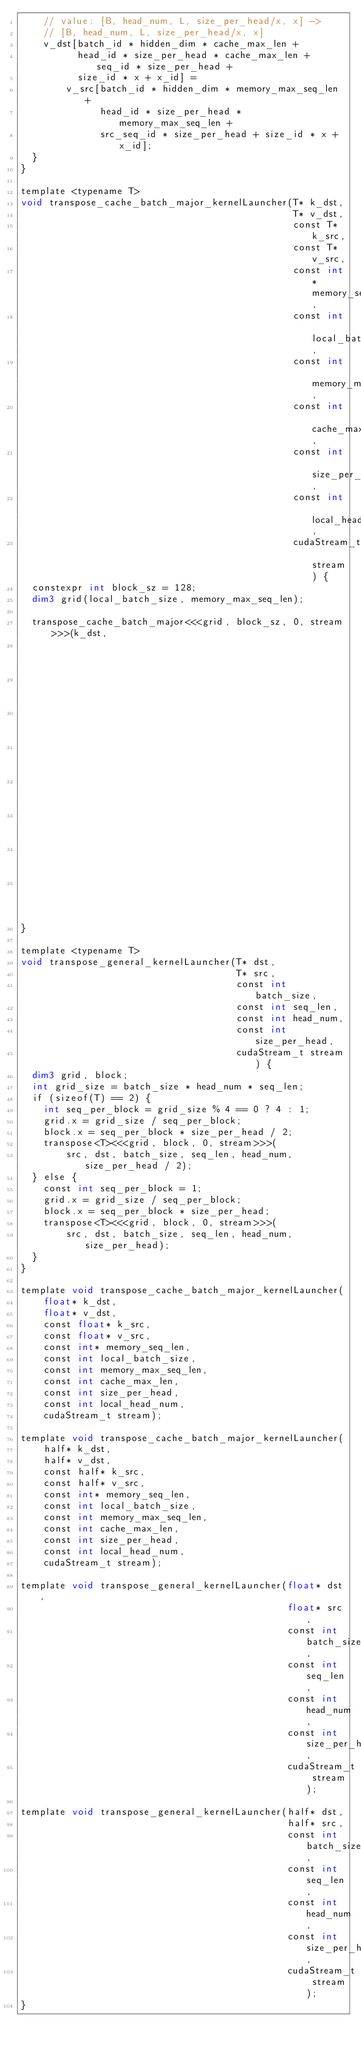<code> <loc_0><loc_0><loc_500><loc_500><_Cuda_>    // value: [B, head_num, L, size_per_head/x, x] ->
    // [B, head_num, L, size_per_head/x, x]
    v_dst[batch_id * hidden_dim * cache_max_len +
          head_id * size_per_head * cache_max_len + seq_id * size_per_head +
          size_id * x + x_id] =
        v_src[batch_id * hidden_dim * memory_max_seq_len +
              head_id * size_per_head * memory_max_seq_len +
              src_seq_id * size_per_head + size_id * x + x_id];
  }
}

template <typename T>
void transpose_cache_batch_major_kernelLauncher(T* k_dst,
                                                T* v_dst,
                                                const T* k_src,
                                                const T* v_src,
                                                const int* memory_seq_len,
                                                const int local_batch_size,
                                                const int memory_max_seq_len,
                                                const int cache_max_len,
                                                const int size_per_head,
                                                const int local_head_num,
                                                cudaStream_t stream) {
  constexpr int block_sz = 128;
  dim3 grid(local_batch_size, memory_max_seq_len);

  transpose_cache_batch_major<<<grid, block_sz, 0, stream>>>(k_dst,
                                                             v_dst,
                                                             k_src,
                                                             v_src,
                                                             memory_seq_len,
                                                             local_head_num,
                                                             size_per_head,
                                                             memory_max_seq_len,
                                                             cache_max_len);
}

template <typename T>
void transpose_general_kernelLauncher(T* dst,
                                      T* src,
                                      const int batch_size,
                                      const int seq_len,
                                      const int head_num,
                                      const int size_per_head,
                                      cudaStream_t stream) {
  dim3 grid, block;
  int grid_size = batch_size * head_num * seq_len;
  if (sizeof(T) == 2) {
    int seq_per_block = grid_size % 4 == 0 ? 4 : 1;
    grid.x = grid_size / seq_per_block;
    block.x = seq_per_block * size_per_head / 2;
    transpose<T><<<grid, block, 0, stream>>>(
        src, dst, batch_size, seq_len, head_num, size_per_head / 2);
  } else {
    const int seq_per_block = 1;
    grid.x = grid_size / seq_per_block;
    block.x = seq_per_block * size_per_head;
    transpose<T><<<grid, block, 0, stream>>>(
        src, dst, batch_size, seq_len, head_num, size_per_head);
  }
}

template void transpose_cache_batch_major_kernelLauncher(
    float* k_dst,
    float* v_dst,
    const float* k_src,
    const float* v_src,
    const int* memory_seq_len,
    const int local_batch_size,
    const int memory_max_seq_len,
    const int cache_max_len,
    const int size_per_head,
    const int local_head_num,
    cudaStream_t stream);

template void transpose_cache_batch_major_kernelLauncher(
    half* k_dst,
    half* v_dst,
    const half* k_src,
    const half* v_src,
    const int* memory_seq_len,
    const int local_batch_size,
    const int memory_max_seq_len,
    const int cache_max_len,
    const int size_per_head,
    const int local_head_num,
    cudaStream_t stream);

template void transpose_general_kernelLauncher(float* dst,
                                               float* src,
                                               const int batch_size,
                                               const int seq_len,
                                               const int head_num,
                                               const int size_per_head,
                                               cudaStream_t stream);

template void transpose_general_kernelLauncher(half* dst,
                                               half* src,
                                               const int batch_size,
                                               const int seq_len,
                                               const int head_num,
                                               const int size_per_head,
                                               cudaStream_t stream);
}
</code> 